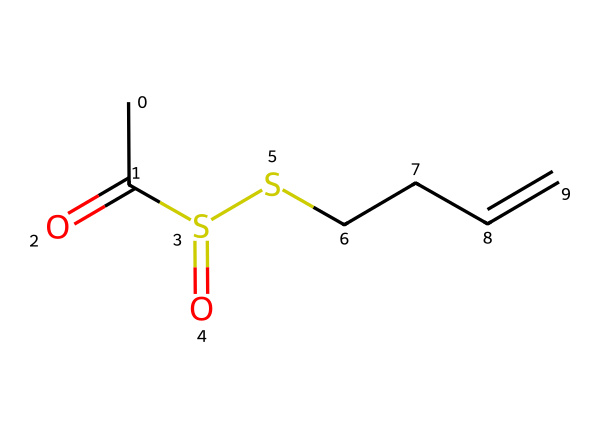What is the name of the compound represented by this structure? The given SMILES represents allicin, a well-known organosulfur compound found in garlic, which is responsible for its characteristic aroma and health benefits.
Answer: allicin How many carbon atoms are present in the structure? By analyzing the SMILES notation, there are a total of 5 carbon atoms represented in the structure (CCCCC).
Answer: 5 How many sulfur atoms are in the chemical structure? The SMILES representation shows two sulfur atoms, indicated by the 'S' symbols in the structure.
Answer: 2 What type of functional groups are present in this compound? The presence of 'S(=O)' indicates sulfonyl groups, and the 'CC=O' indicates a carbonyl group (aldehyde) at the end, which are the main functional groups in allicin.
Answer: sulfonyl and carbonyl What is the main reason for allicin's strong odor? Allicin contains sulfur atoms, which often lead to pungent and strong odors in organosulfur compounds; the combination of these functional groups results in the characteristic smell of garlic.
Answer: sulfur atoms What type of reaction can allicin participate in due to its structure? Allicin's structure contains a double bond and sulfur functional groups, which can participate in various chemical reactions, including nucleophilic attacks and redox reactions due to its reactivity.
Answer: nucleophilic and redox reactions 